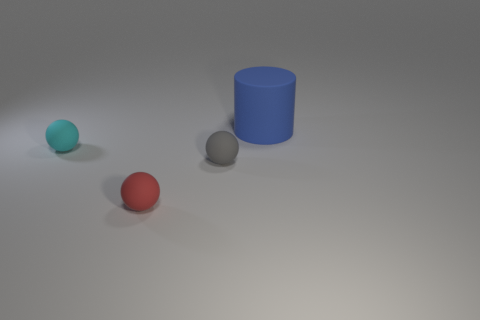What time of day does the lighting in the image suggest? The lighting in the image is soft and diffused, with shadows that fall subtly to the right of the objects. This might suggest indoor lighting, as it's not possible to determine the time of day from this scene. 